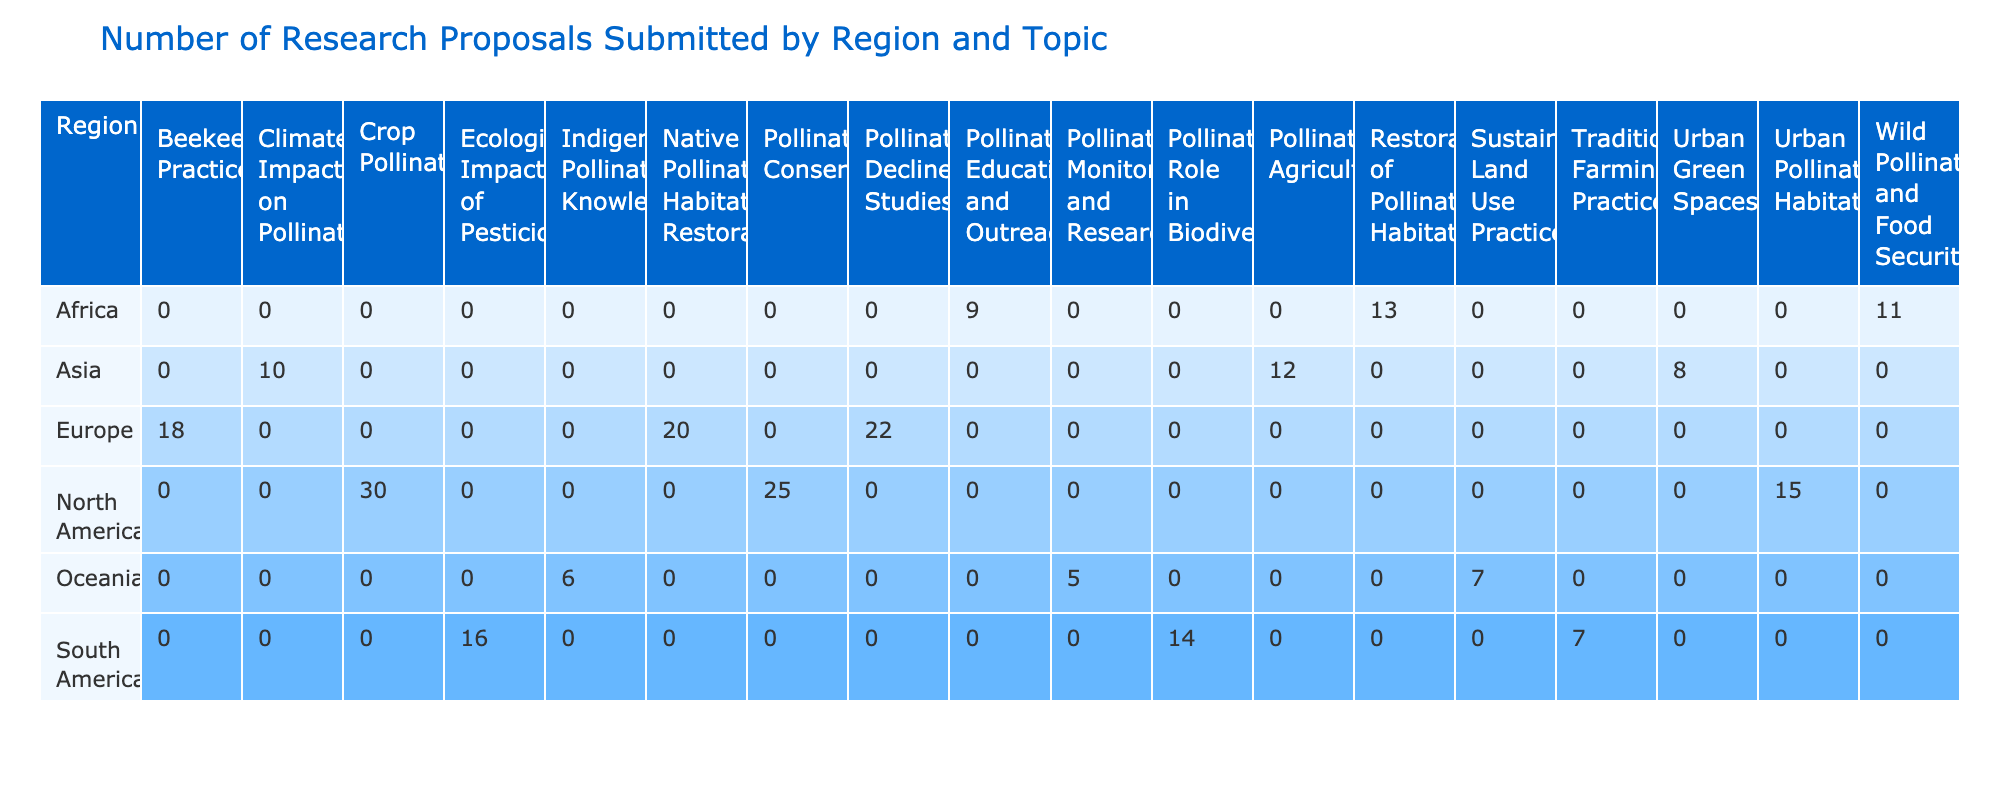What is the total number of research proposals submitted from North America? The proposals submitted from North America are: Pollinator Conservation (25), Crop Pollination (30), and Urban Pollinator Habitats (15). Adding these gives us 25 + 30 + 15 = 70.
Answer: 70 Which topic has the highest number of proposals in Europe? In Europe, the topics and their proposals are: Pollinator Decline Studies (22), Beekeeping Practices (18), and Native Pollinator Habitat Restoration (20). The highest value is 22 for Pollinator Decline Studies.
Answer: Pollinator Decline Studies How many proposals are focused on pollinator education and outreach in Africa? In Africa, the topic Pollinator Education and Outreach has 9 proposals. This is directly listed in the table.
Answer: 9 What is the average number of proposals submitted in South America? In South America, the proposals are: Pollinator Role in Biodiversity (14), Ecological Impact of Pesticides (16), and Traditional Farming Practices (7). The total number of proposals is 14 + 16 + 7 = 37. There are 3 topics, so the average is 37 / 3 = 12.33.
Answer: 12.33 Is there any region with over 30 proposals in the Crop Pollination topic? Checking the Crop Pollination column, North America has 30 proposals, but there are no regions with more than 30. Thus, the answer is no.
Answer: No What is the overall trend in proposal submissions across regions regarding pollinator-friendly practices? The data shows proposals from various regions focused on pollinator-friendly practices: North America (15), Europe (20), Asia (12), and South America (16). The total is 15 + 20 + 12 + 16 = 63, indicating a general interest across these regions.
Answer: 63 Which region has submitted the least number of proposals in total? By calculating the total for each region, we find: North America (70), Europe (60), Asia (30), South America (37), Africa (33), and Oceania (18). The least total is from Oceania with 18 proposals.
Answer: Oceania How many proposals related to pollinator conservation have been submitted in total across all regions? The data shows only one region with Pollinator Conservation proposals, North America with 25 proposals. No other region has this topic listed. Thus, the total for this topic is 25.
Answer: 25 Which region has the highest collective number of proposals across all topics? Calculating total proposals: North America (70), Europe (60), Asia (30), South America (37), Africa (33), and Oceania (18). The highest is North America with 70 proposals which is the largest total among all.
Answer: North America 